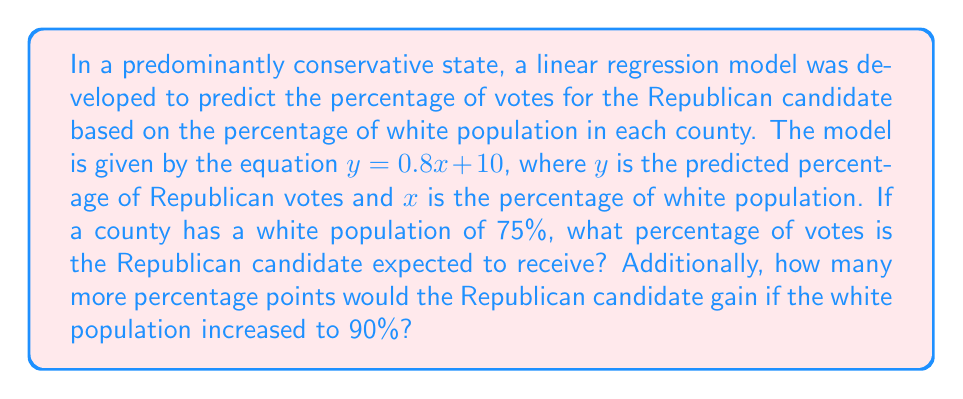Give your solution to this math problem. 1. We are given the linear regression equation: $y = 0.8x + 10$

2. To find the expected percentage of Republican votes for a county with 75% white population:
   Substitute $x = 75$ into the equation:
   $y = 0.8(75) + 10$
   $y = 60 + 10 = 70$

3. To find the gain if the white population increased to 90%:
   a. Calculate the predicted percentage for 90% white population:
      $y = 0.8(90) + 10$
      $y = 72 + 10 = 82$

   b. Subtract the result for 75% from the result for 90%:
      $82 - 70 = 12$

Therefore, the Republican candidate is expected to receive 70% of the votes in a county with 75% white population, and would gain an additional 12 percentage points if the white population increased to 90%.
Answer: 70%; 12 percentage points 